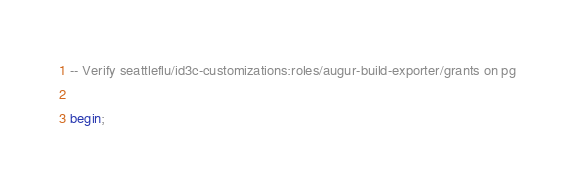<code> <loc_0><loc_0><loc_500><loc_500><_SQL_>-- Verify seattleflu/id3c-customizations:roles/augur-build-exporter/grants on pg

begin;
</code> 